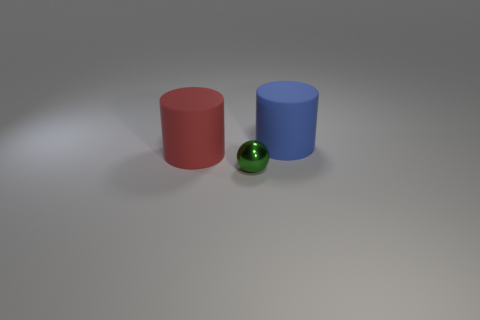Add 3 green things. How many objects exist? 6 Subtract all cylinders. How many objects are left? 1 Add 2 blue rubber objects. How many blue rubber objects exist? 3 Subtract 0 gray blocks. How many objects are left? 3 Subtract all gray cylinders. Subtract all big blue objects. How many objects are left? 2 Add 2 small green things. How many small green things are left? 3 